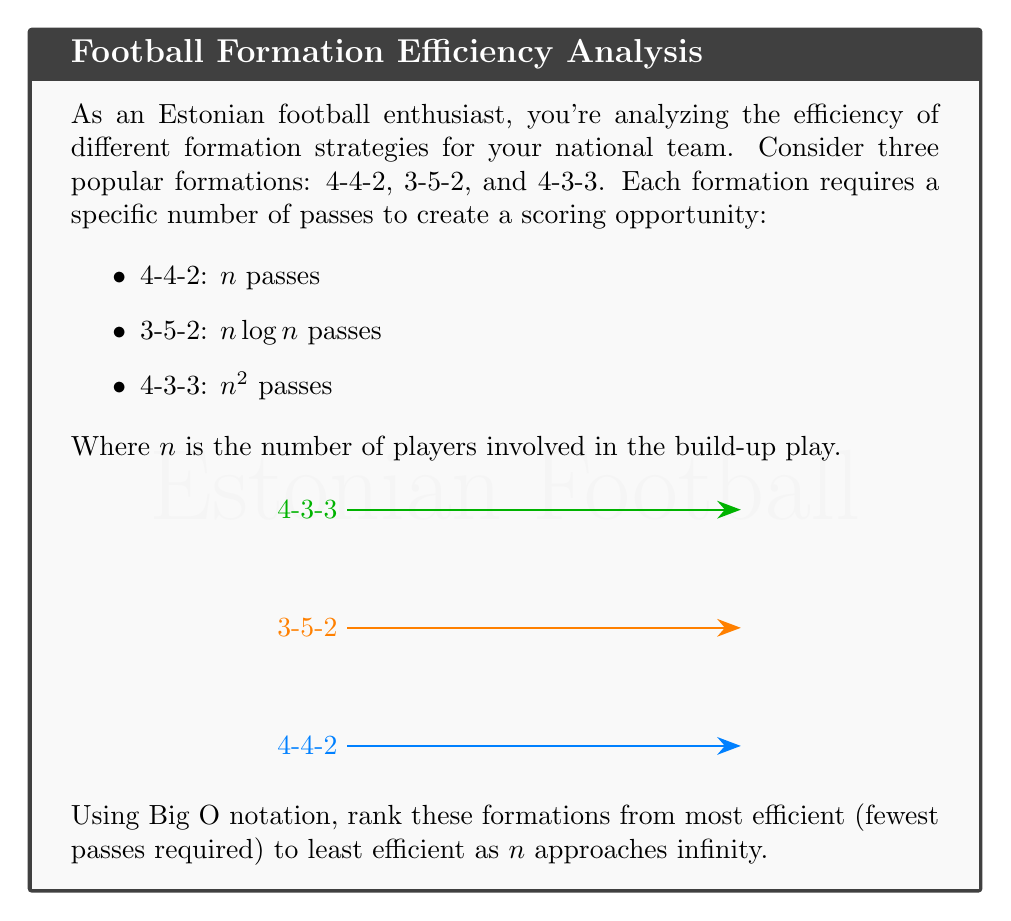Teach me how to tackle this problem. To rank the formations based on their efficiency using Big O notation, we need to compare the growth rates of the functions as $n$ approaches infinity. Let's analyze each formation:

1. 4-4-2 formation: $O(n)$
   This is a linear function, which grows steadily as $n$ increases.

2. 3-5-2 formation: $O(n \log n)$
   This function grows faster than linear but slower than quadratic.

3. 4-3-3 formation: $O(n^2)$
   This is a quadratic function, which grows much faster than the other two as $n$ increases.

To rank them from most efficient (fewest passes required) to least efficient, we need to order them from slowest-growing to fastest-growing function:

$O(n) < O(n \log n) < O(n^2)$

Therefore, the ranking from most efficient to least efficient is:

1. 4-4-2: $O(n)$
2. 3-5-2: $O(n \log n)$
3. 4-3-3: $O(n^2)$

As $n$ approaches infinity, the 4-4-2 formation will require the fewest passes to create a scoring opportunity, followed by the 3-5-2 formation, and finally the 4-3-3 formation will require the most passes.
Answer: 4-4-2 $<$ 3-5-2 $<$ 4-3-3 